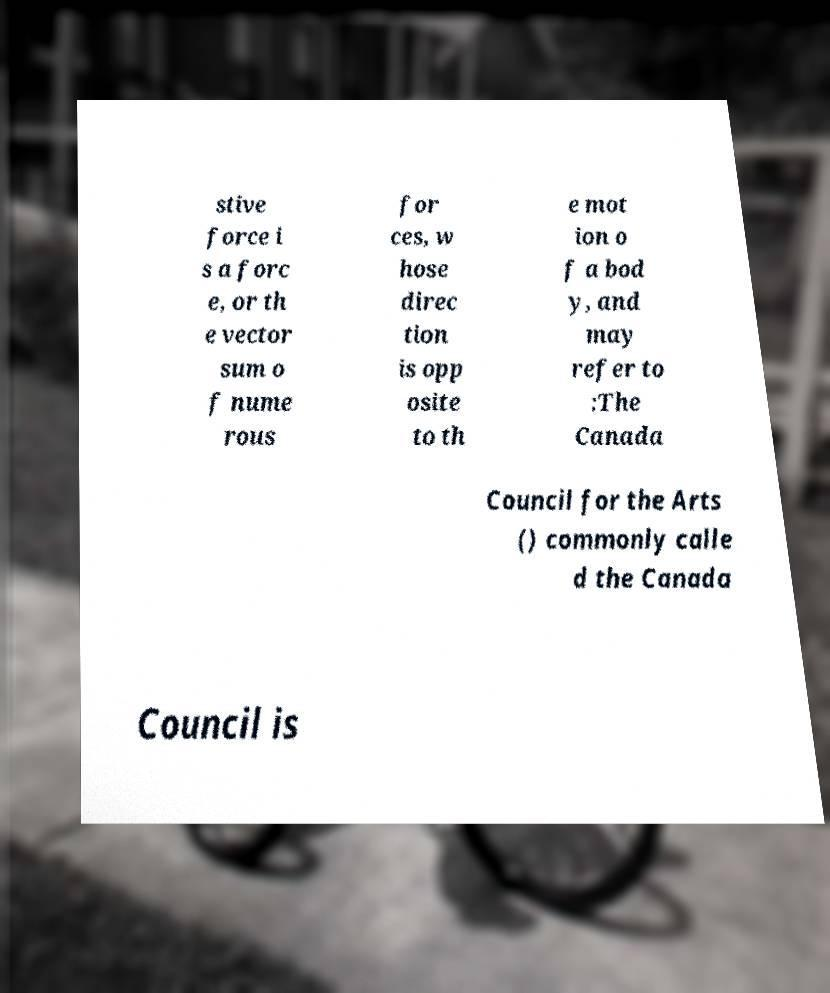There's text embedded in this image that I need extracted. Can you transcribe it verbatim? stive force i s a forc e, or th e vector sum o f nume rous for ces, w hose direc tion is opp osite to th e mot ion o f a bod y, and may refer to :The Canada Council for the Arts () commonly calle d the Canada Council is 